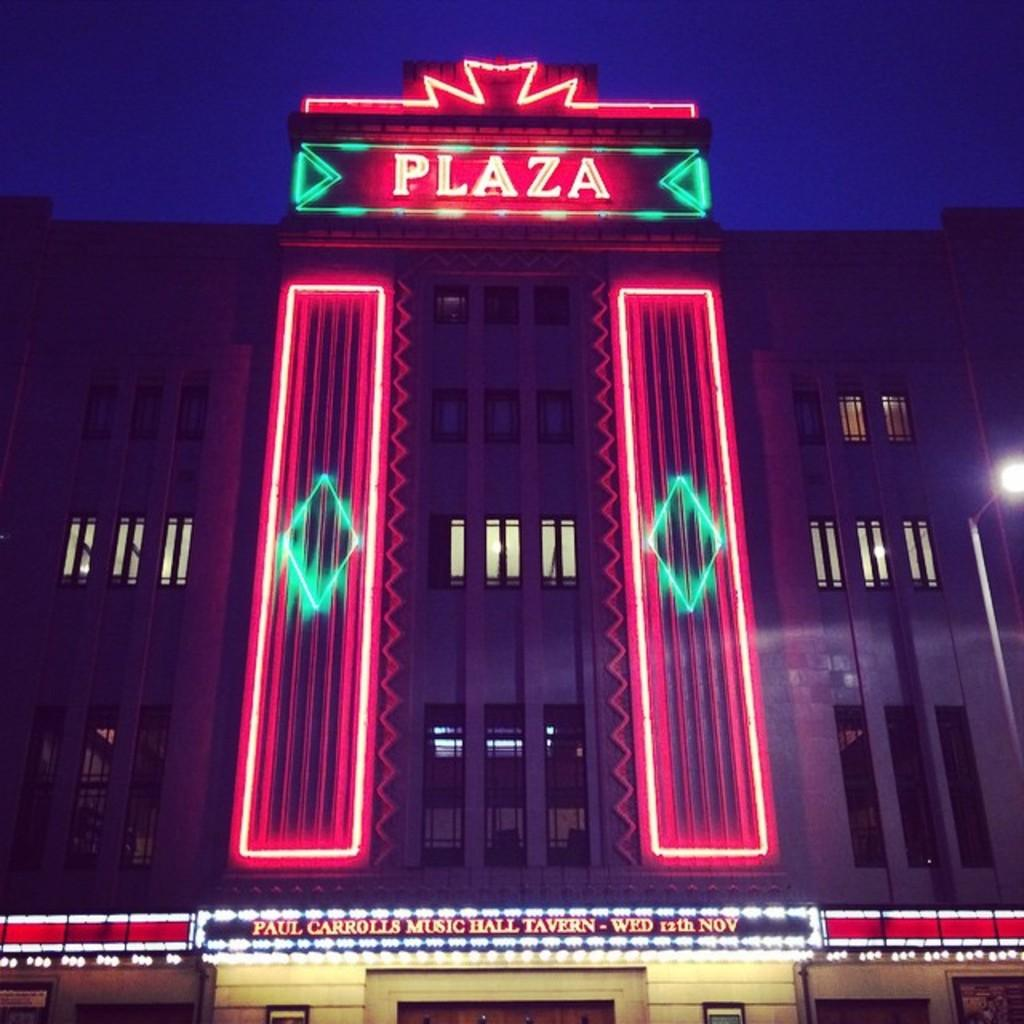What is the main subject in the foreground of the image? There is a building in the foreground of the image. What feature can be observed on the building? The building has windows. What can be seen in the background of the image? The sky is blue and visible in the image. What time of day was the image taken? The image was taken during nighttime. What type of waste can be seen in the image? There is no waste present in the image. What toys are visible in the image? There are no toys visible in the image. 